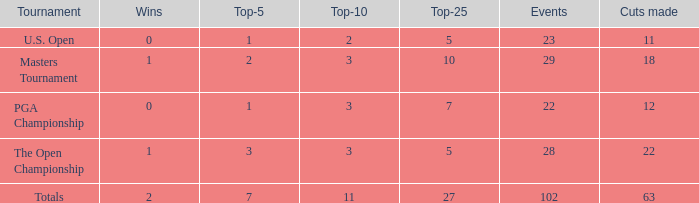How many vuts made for a player with 2 wins and under 7 top 5s? None. 